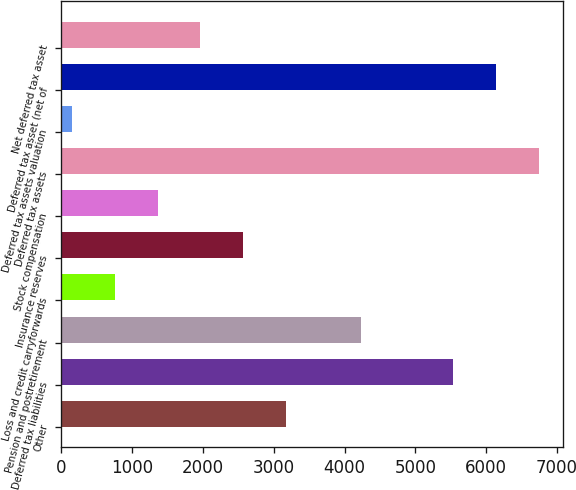<chart> <loc_0><loc_0><loc_500><loc_500><bar_chart><fcel>Other<fcel>Deferred tax liabilities<fcel>Pension and postretirement<fcel>Loss and credit carryforwards<fcel>Insurance reserves<fcel>Stock compensation<fcel>Deferred tax assets<fcel>Deferred tax assets valuation<fcel>Deferred tax asset (net of<fcel>Net deferred tax asset<nl><fcel>3167.5<fcel>5538<fcel>4236<fcel>760.7<fcel>2565.8<fcel>1362.4<fcel>6741.4<fcel>159<fcel>6139.7<fcel>1964.1<nl></chart> 